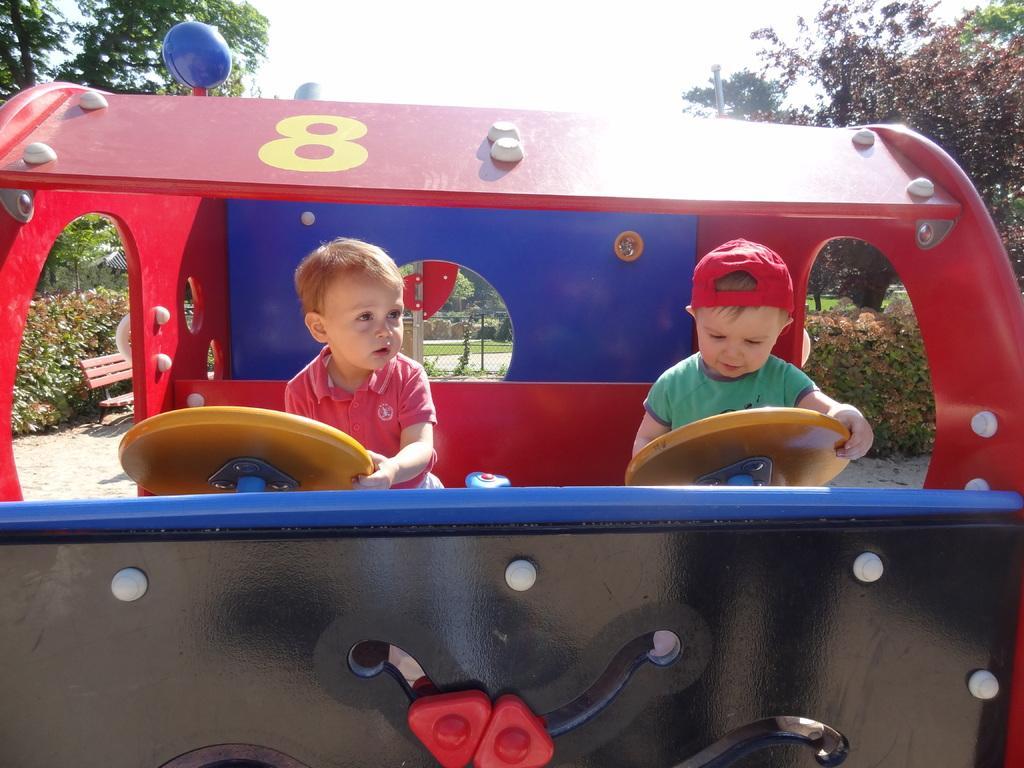How would you summarize this image in a sentence or two? In this image I see children who are in the toy vehicle which is of black, white, red and blue in color and I see a number over here. In the background I see the bushes, a bench, trees and the sky. 